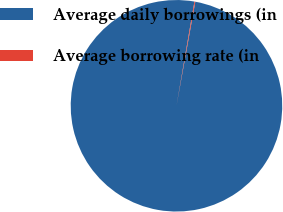<chart> <loc_0><loc_0><loc_500><loc_500><pie_chart><fcel>Average daily borrowings (in<fcel>Average borrowing rate (in<nl><fcel>99.87%<fcel>0.13%<nl></chart> 